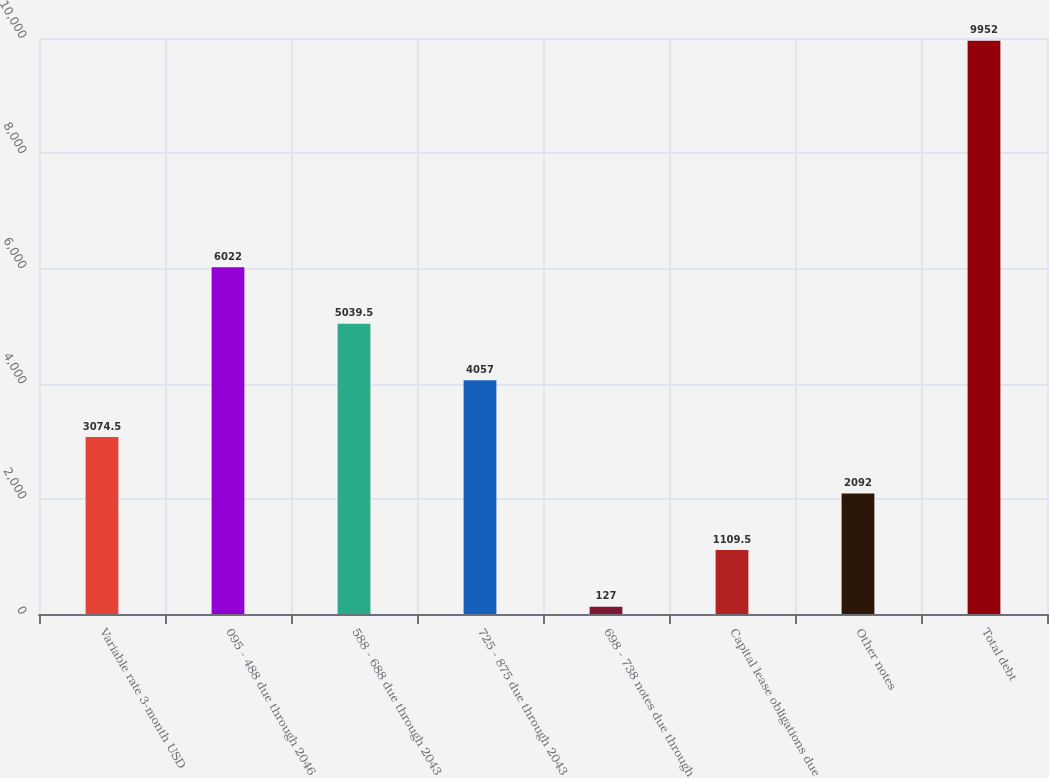Convert chart. <chart><loc_0><loc_0><loc_500><loc_500><bar_chart><fcel>Variable rate 3-month USD<fcel>095 - 488 due through 2046<fcel>588 - 688 due through 2043<fcel>725 - 875 due through 2043<fcel>698 - 738 notes due through<fcel>Capital lease obligations due<fcel>Other notes<fcel>Total debt<nl><fcel>3074.5<fcel>6022<fcel>5039.5<fcel>4057<fcel>127<fcel>1109.5<fcel>2092<fcel>9952<nl></chart> 